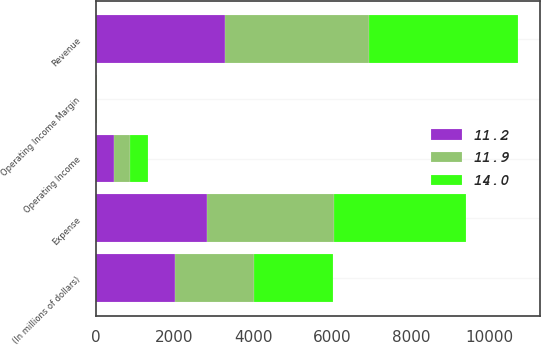Convert chart. <chart><loc_0><loc_0><loc_500><loc_500><stacked_bar_chart><ecel><fcel>(In millions of dollars)<fcel>Revenue<fcel>Expense<fcel>Operating Income<fcel>Operating Income Margin<nl><fcel>14<fcel>2005<fcel>3802<fcel>3351<fcel>451<fcel>11.9<nl><fcel>11.9<fcel>2004<fcel>3637<fcel>3228<fcel>409<fcel>11.2<nl><fcel>11.2<fcel>2003<fcel>3290<fcel>2829<fcel>461<fcel>14<nl></chart> 